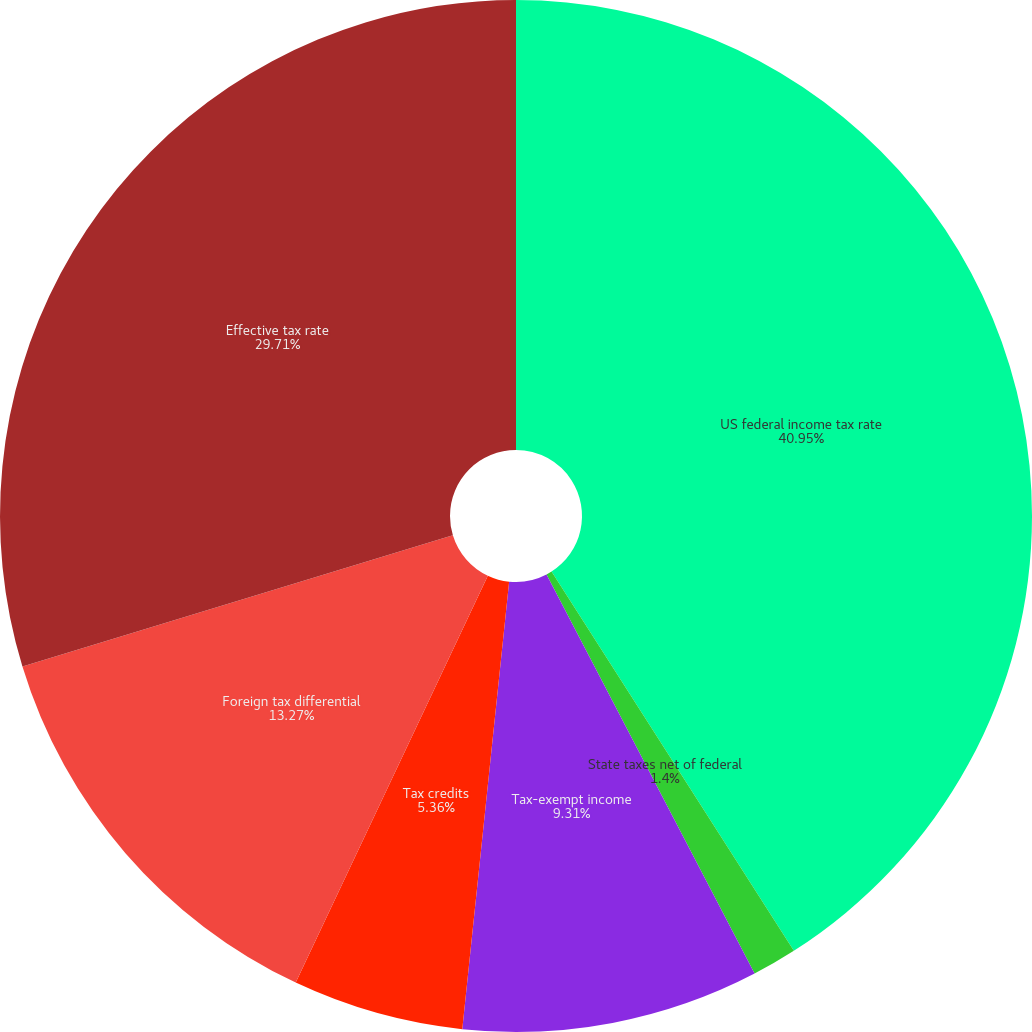Convert chart. <chart><loc_0><loc_0><loc_500><loc_500><pie_chart><fcel>US federal income tax rate<fcel>State taxes net of federal<fcel>Tax-exempt income<fcel>Tax credits<fcel>Foreign tax differential<fcel>Effective tax rate<nl><fcel>40.95%<fcel>1.4%<fcel>9.31%<fcel>5.36%<fcel>13.27%<fcel>29.71%<nl></chart> 